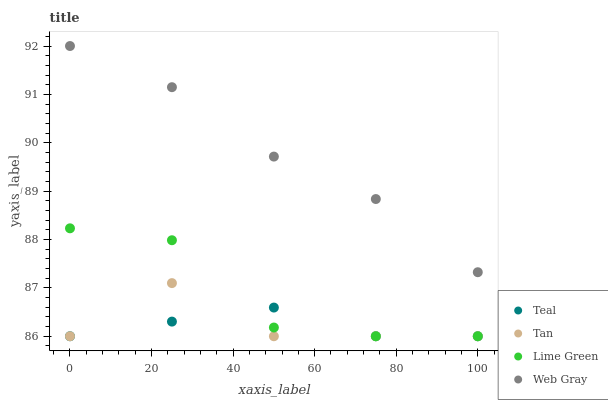Does Teal have the minimum area under the curve?
Answer yes or no. Yes. Does Web Gray have the maximum area under the curve?
Answer yes or no. Yes. Does Lime Green have the minimum area under the curve?
Answer yes or no. No. Does Lime Green have the maximum area under the curve?
Answer yes or no. No. Is Teal the smoothest?
Answer yes or no. Yes. Is Lime Green the roughest?
Answer yes or no. Yes. Is Web Gray the smoothest?
Answer yes or no. No. Is Web Gray the roughest?
Answer yes or no. No. Does Tan have the lowest value?
Answer yes or no. Yes. Does Web Gray have the lowest value?
Answer yes or no. No. Does Web Gray have the highest value?
Answer yes or no. Yes. Does Lime Green have the highest value?
Answer yes or no. No. Is Lime Green less than Web Gray?
Answer yes or no. Yes. Is Web Gray greater than Lime Green?
Answer yes or no. Yes. Does Tan intersect Lime Green?
Answer yes or no. Yes. Is Tan less than Lime Green?
Answer yes or no. No. Is Tan greater than Lime Green?
Answer yes or no. No. Does Lime Green intersect Web Gray?
Answer yes or no. No. 